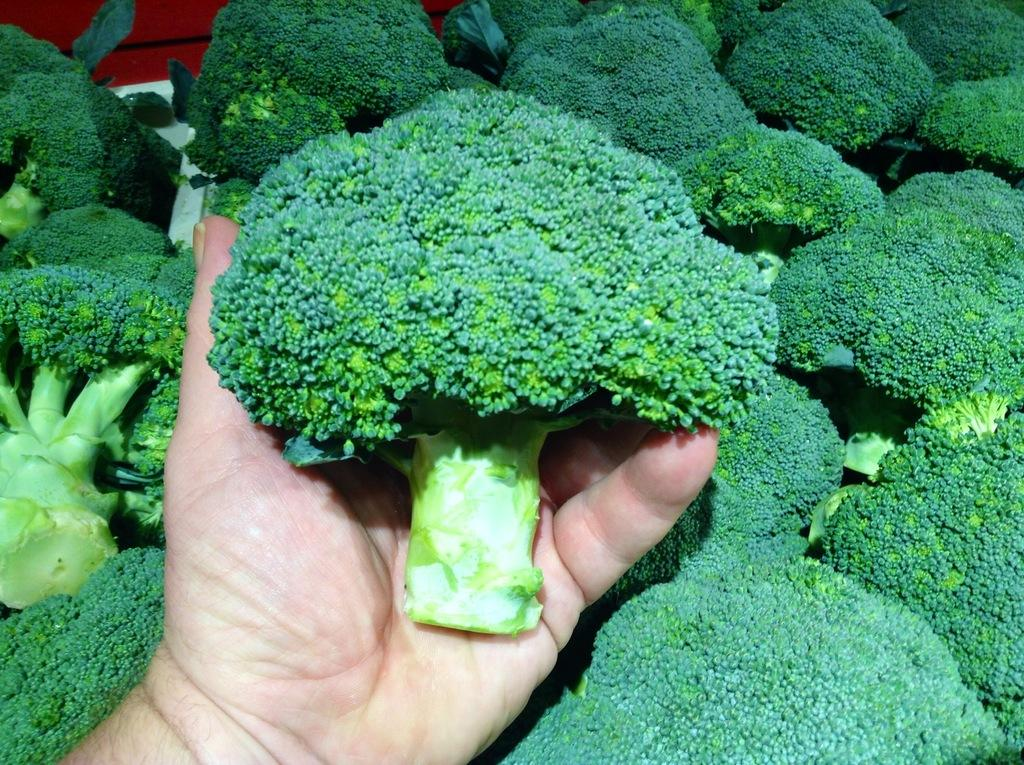What is placed on the table in the image? There are vegetables placed on a table in the image. What is the person in the image doing with the vegetables? One person is holding the vegetables in the image. What advice does the queen give about the vegetables in the image? There is no queen present in the image, and therefore no advice can be given about the vegetables. 